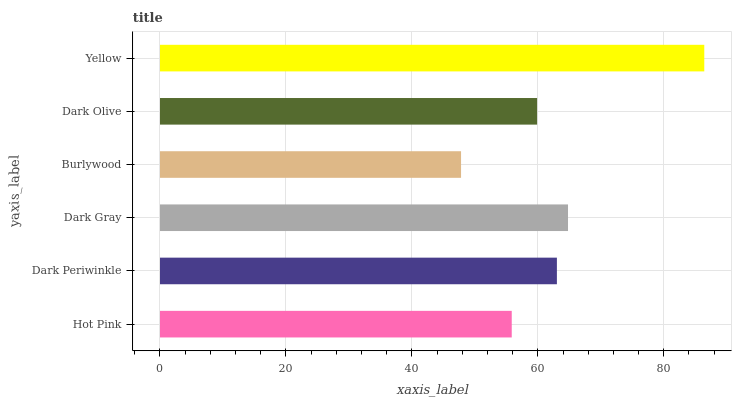Is Burlywood the minimum?
Answer yes or no. Yes. Is Yellow the maximum?
Answer yes or no. Yes. Is Dark Periwinkle the minimum?
Answer yes or no. No. Is Dark Periwinkle the maximum?
Answer yes or no. No. Is Dark Periwinkle greater than Hot Pink?
Answer yes or no. Yes. Is Hot Pink less than Dark Periwinkle?
Answer yes or no. Yes. Is Hot Pink greater than Dark Periwinkle?
Answer yes or no. No. Is Dark Periwinkle less than Hot Pink?
Answer yes or no. No. Is Dark Periwinkle the high median?
Answer yes or no. Yes. Is Dark Olive the low median?
Answer yes or no. Yes. Is Dark Olive the high median?
Answer yes or no. No. Is Hot Pink the low median?
Answer yes or no. No. 